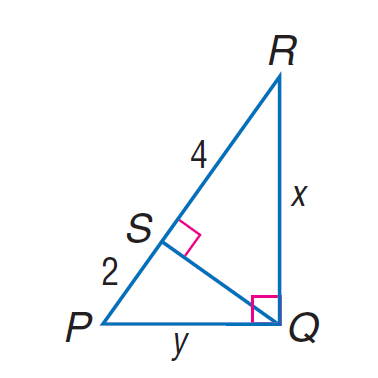Question: Find y in \triangle P Q R.
Choices:
A. 2 \sqrt { 3 }
B. 2 \sqrt { 6 }
C. 4 \sqrt { 3 }
D. 4 \sqrt { 6 }
Answer with the letter. Answer: A Question: Find x in \triangle P Q R.
Choices:
A. 2 \sqrt { 3 }
B. 2 \sqrt { 6 }
C. 4 \sqrt { 3 }
D. 4 \sqrt { 6 }
Answer with the letter. Answer: B 